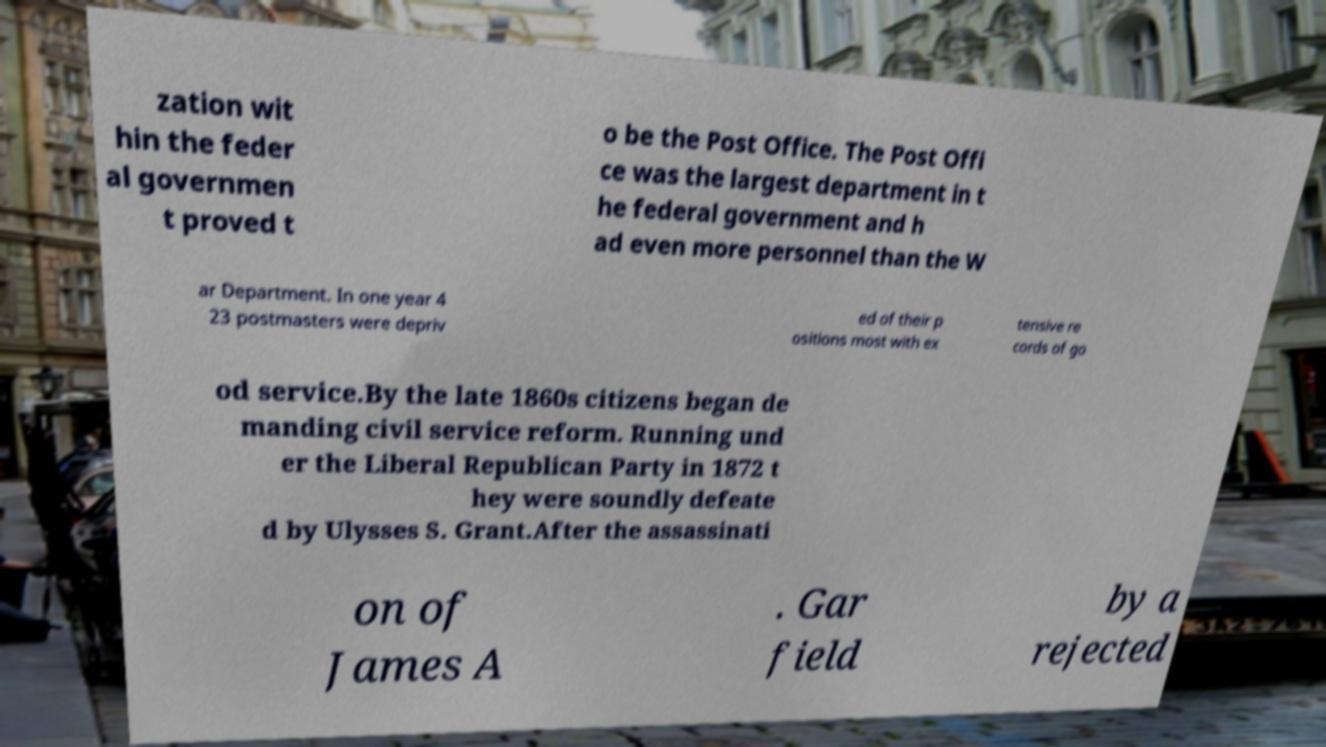I need the written content from this picture converted into text. Can you do that? zation wit hin the feder al governmen t proved t o be the Post Office. The Post Offi ce was the largest department in t he federal government and h ad even more personnel than the W ar Department. In one year 4 23 postmasters were depriv ed of their p ositions most with ex tensive re cords of go od service.By the late 1860s citizens began de manding civil service reform. Running und er the Liberal Republican Party in 1872 t hey were soundly defeate d by Ulysses S. Grant.After the assassinati on of James A . Gar field by a rejected 